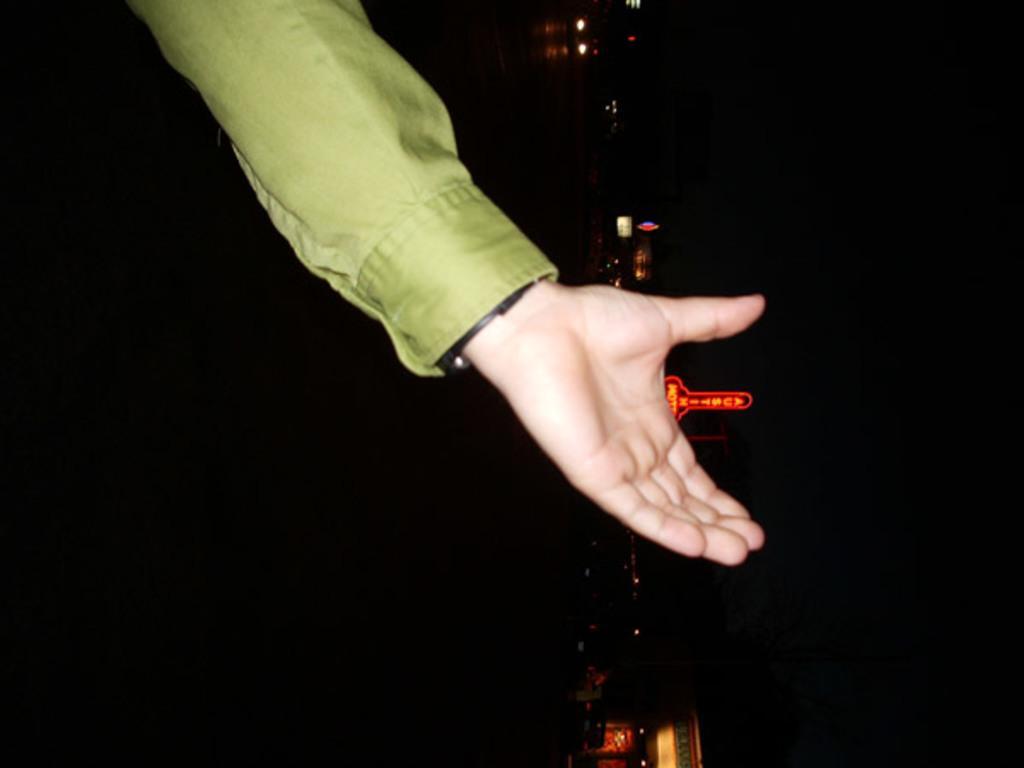Please provide a concise description of this image. Here we can see hand of a person. There is a dark background and we can see lights and boards. 